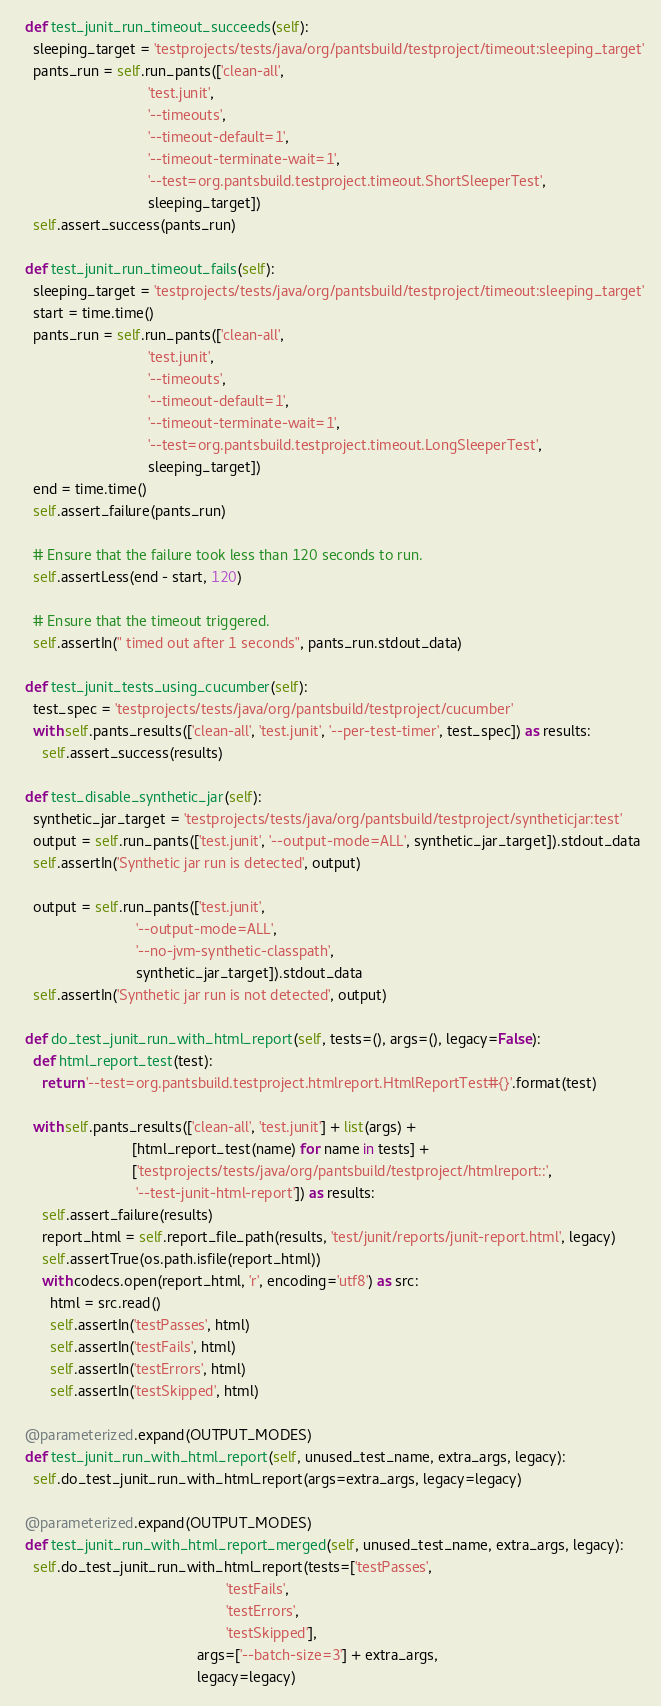Convert code to text. <code><loc_0><loc_0><loc_500><loc_500><_Python_>  def test_junit_run_timeout_succeeds(self):
    sleeping_target = 'testprojects/tests/java/org/pantsbuild/testproject/timeout:sleeping_target'
    pants_run = self.run_pants(['clean-all',
                                'test.junit',
                                '--timeouts',
                                '--timeout-default=1',
                                '--timeout-terminate-wait=1',
                                '--test=org.pantsbuild.testproject.timeout.ShortSleeperTest',
                                sleeping_target])
    self.assert_success(pants_run)

  def test_junit_run_timeout_fails(self):
    sleeping_target = 'testprojects/tests/java/org/pantsbuild/testproject/timeout:sleeping_target'
    start = time.time()
    pants_run = self.run_pants(['clean-all',
                                'test.junit',
                                '--timeouts',
                                '--timeout-default=1',
                                '--timeout-terminate-wait=1',
                                '--test=org.pantsbuild.testproject.timeout.LongSleeperTest',
                                sleeping_target])
    end = time.time()
    self.assert_failure(pants_run)

    # Ensure that the failure took less than 120 seconds to run.
    self.assertLess(end - start, 120)

    # Ensure that the timeout triggered.
    self.assertIn(" timed out after 1 seconds", pants_run.stdout_data)

  def test_junit_tests_using_cucumber(self):
    test_spec = 'testprojects/tests/java/org/pantsbuild/testproject/cucumber'
    with self.pants_results(['clean-all', 'test.junit', '--per-test-timer', test_spec]) as results:
      self.assert_success(results)

  def test_disable_synthetic_jar(self):
    synthetic_jar_target = 'testprojects/tests/java/org/pantsbuild/testproject/syntheticjar:test'
    output = self.run_pants(['test.junit', '--output-mode=ALL', synthetic_jar_target]).stdout_data
    self.assertIn('Synthetic jar run is detected', output)

    output = self.run_pants(['test.junit',
                             '--output-mode=ALL',
                             '--no-jvm-synthetic-classpath',
                             synthetic_jar_target]).stdout_data
    self.assertIn('Synthetic jar run is not detected', output)

  def do_test_junit_run_with_html_report(self, tests=(), args=(), legacy=False):
    def html_report_test(test):
      return '--test=org.pantsbuild.testproject.htmlreport.HtmlReportTest#{}'.format(test)

    with self.pants_results(['clean-all', 'test.junit'] + list(args) +
                            [html_report_test(name) for name in tests] +
                            ['testprojects/tests/java/org/pantsbuild/testproject/htmlreport::',
                             '--test-junit-html-report']) as results:
      self.assert_failure(results)
      report_html = self.report_file_path(results, 'test/junit/reports/junit-report.html', legacy)
      self.assertTrue(os.path.isfile(report_html))
      with codecs.open(report_html, 'r', encoding='utf8') as src:
        html = src.read()
        self.assertIn('testPasses', html)
        self.assertIn('testFails', html)
        self.assertIn('testErrors', html)
        self.assertIn('testSkipped', html)

  @parameterized.expand(OUTPUT_MODES)
  def test_junit_run_with_html_report(self, unused_test_name, extra_args, legacy):
    self.do_test_junit_run_with_html_report(args=extra_args, legacy=legacy)

  @parameterized.expand(OUTPUT_MODES)
  def test_junit_run_with_html_report_merged(self, unused_test_name, extra_args, legacy):
    self.do_test_junit_run_with_html_report(tests=['testPasses',
                                                   'testFails',
                                                   'testErrors',
                                                   'testSkipped'],
                                            args=['--batch-size=3'] + extra_args,
                                            legacy=legacy)
</code> 